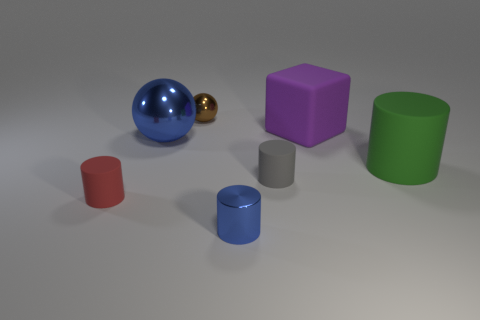Which objects in the scene can reflect light most effectively? The objects with the most reflective surfaces in this scene are the gold and blue spherical balls. Their shiny exteriors are capable of reflecting the environment and light around them quite prominently. 